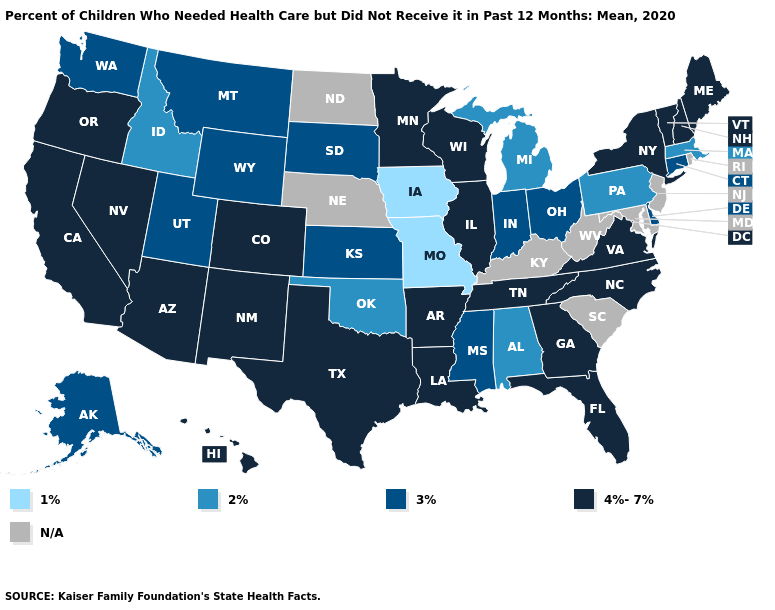Among the states that border Arizona , does Utah have the highest value?
Short answer required. No. Does Ohio have the highest value in the USA?
Quick response, please. No. Name the states that have a value in the range 4%-7%?
Give a very brief answer. Arizona, Arkansas, California, Colorado, Florida, Georgia, Hawaii, Illinois, Louisiana, Maine, Minnesota, Nevada, New Hampshire, New Mexico, New York, North Carolina, Oregon, Tennessee, Texas, Vermont, Virginia, Wisconsin. Name the states that have a value in the range N/A?
Quick response, please. Kentucky, Maryland, Nebraska, New Jersey, North Dakota, Rhode Island, South Carolina, West Virginia. What is the value of Virginia?
Short answer required. 4%-7%. What is the value of Kansas?
Write a very short answer. 3%. Which states hav the highest value in the MidWest?
Concise answer only. Illinois, Minnesota, Wisconsin. Name the states that have a value in the range 1%?
Quick response, please. Iowa, Missouri. Among the states that border South Dakota , does Montana have the lowest value?
Short answer required. No. Name the states that have a value in the range 1%?
Keep it brief. Iowa, Missouri. Among the states that border Illinois , does Missouri have the lowest value?
Quick response, please. Yes. Does the map have missing data?
Keep it brief. Yes. What is the value of Missouri?
Short answer required. 1%. How many symbols are there in the legend?
Keep it brief. 5. 